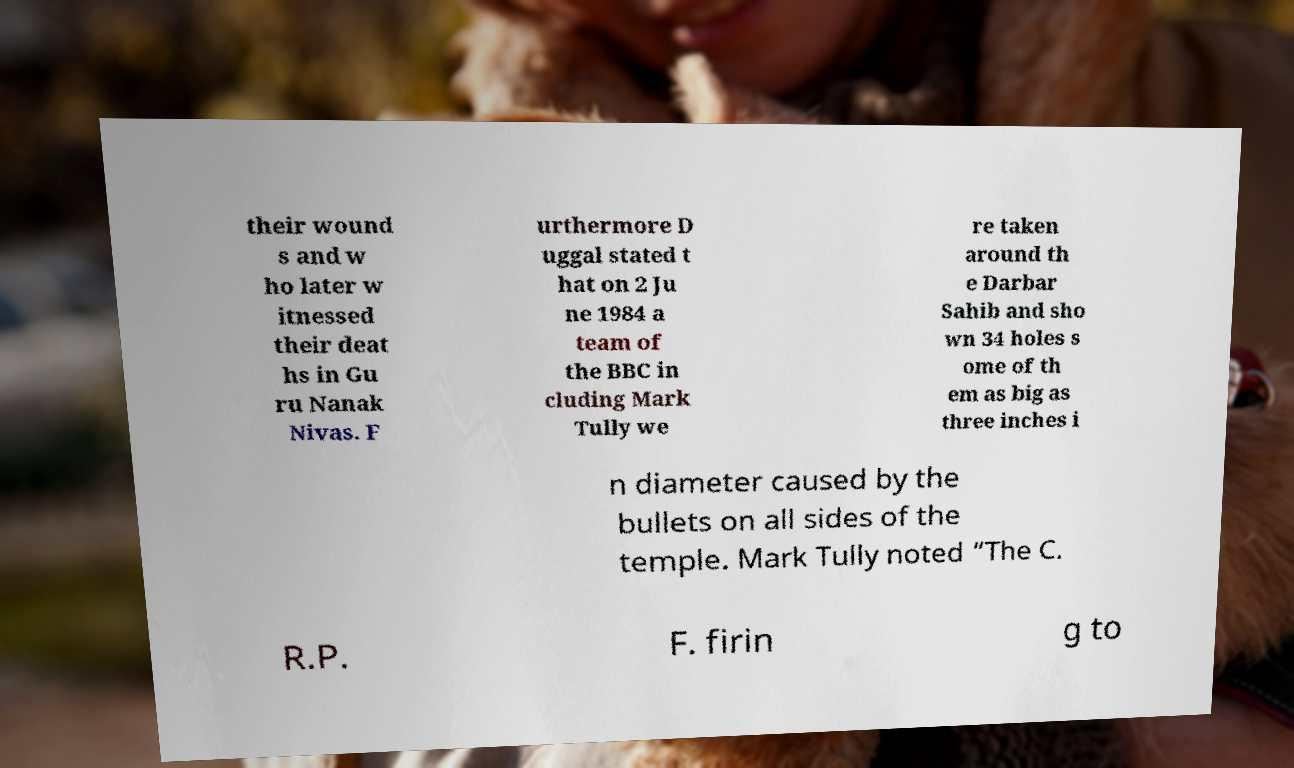Can you read and provide the text displayed in the image?This photo seems to have some interesting text. Can you extract and type it out for me? their wound s and w ho later w itnessed their deat hs in Gu ru Nanak Nivas. F urthermore D uggal stated t hat on 2 Ju ne 1984 a team of the BBC in cluding Mark Tully we re taken around th e Darbar Sahib and sho wn 34 holes s ome of th em as big as three inches i n diameter caused by the bullets on all sides of the temple. Mark Tully noted “The C. R.P. F. firin g to 